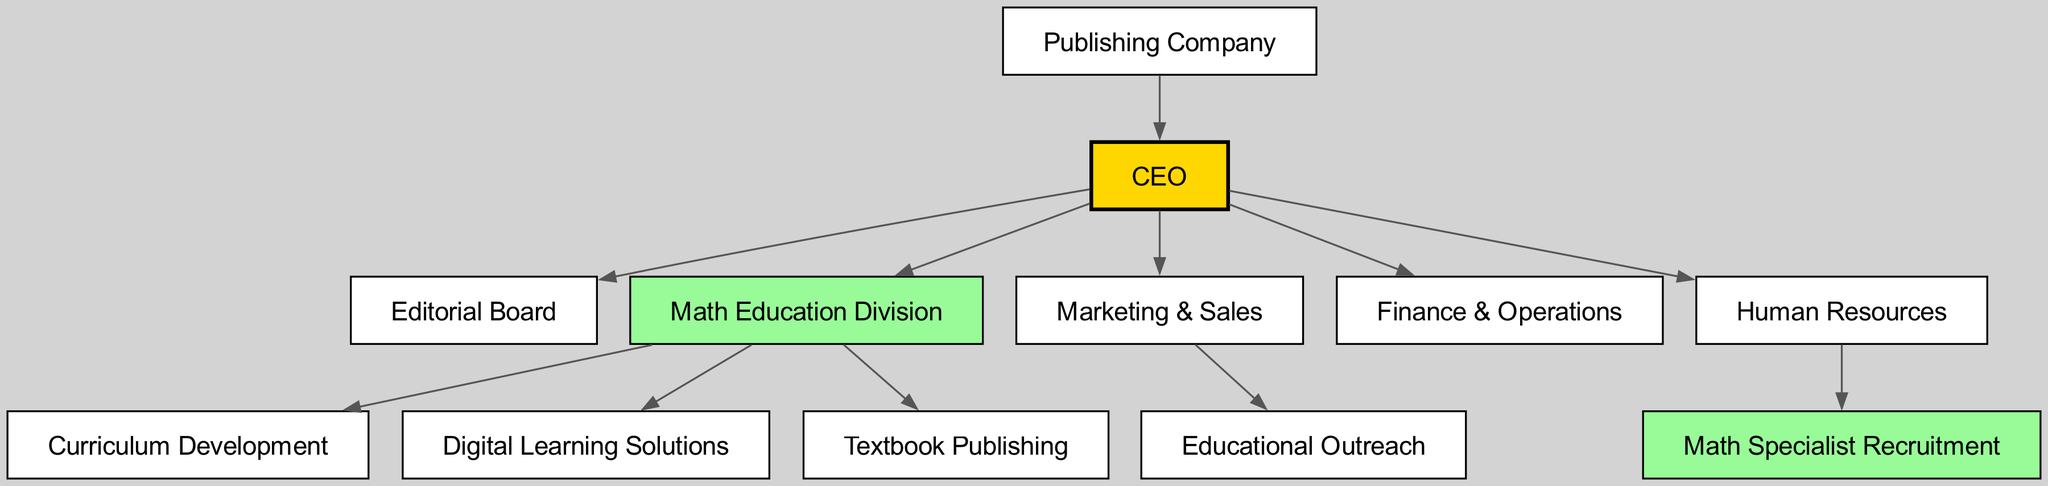What is the role of the top node in the diagram? The top node in the diagram represents the CEO of the publishing company, who oversees all other divisions and departments within the company.
Answer: CEO How many divisions focus on math education? The diagram shows three specific divisions dedicated to math education: Curriculum Development, Digital Learning Solutions, and Textbook Publishing, indicating a total of three divisions.
Answer: 3 Which department is responsible for marketing outreach related to education? The department titled "Educational Outreach" is identified under the "Marketing & Sales" division, indicating its responsibility for marketing outreach related to education.
Answer: Educational Outreach Is there a node representing Math Specialist Recruitment? Yes, there is a node labeled "Math Specialist Recruitment" under the Human Resources division, which signifies its specific function of recruiting math specialists.
Answer: Yes Which department falls under the Human Resources category? The "Math Specialist Recruitment" node is the only one that falls under the Human Resources division, indicating its singular focus within that category.
Answer: Math Specialist Recruitment How many total departments are represented in the diagram? The diagram illustrates a total of six departments: CEO, Editorial Board, Math Education Division (with three subdivisions), Marketing & Sales, Finance & Operations, and Human Resources, summing them up to six.
Answer: 6 Which division contains Curriculum Development? The "Curriculum Development" is part of the "Math Education Division." This indicates its focus on developing educational content specifically for math.
Answer: Math Education Division How does the Math Education Division relate to the overall structure? The Math Education Division is a sub-division under the CEO, comprised of key departments specifically aimed at enhancing math education, showing its central role within the overall structure.
Answer: Under CEO What color represents the Math Education Division in the diagram? The Math Education Division is represented in the diagram with a light green color, distinguishing it visually from other divisions.
Answer: Light green 